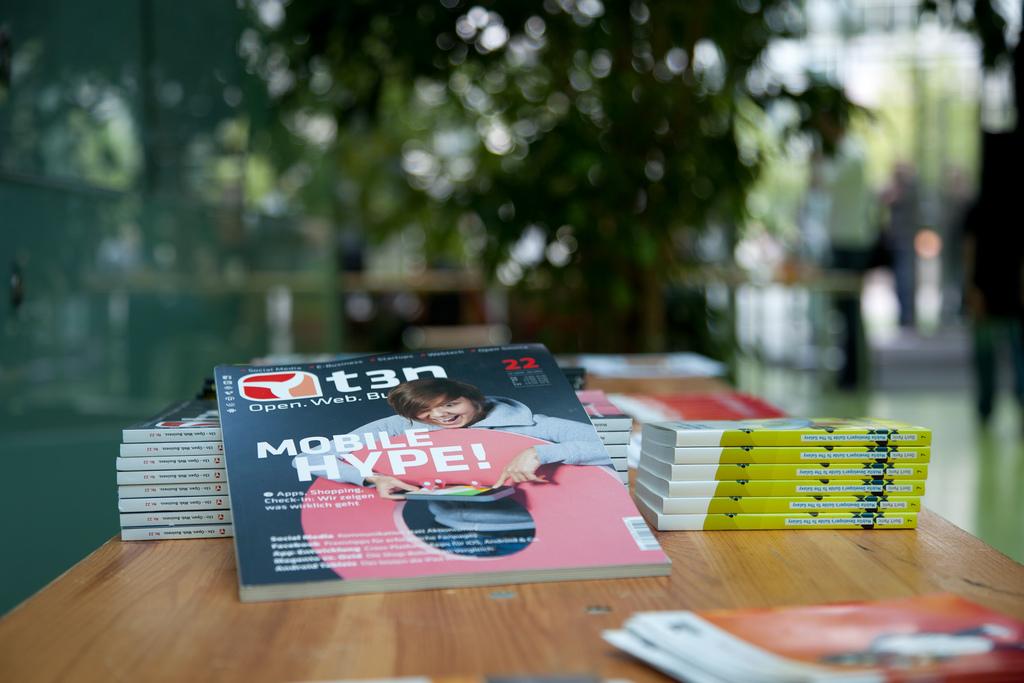What is the name of the magazine?
Keep it short and to the point. T3n. What is the magazine about?
Make the answer very short. Mobile hype. 